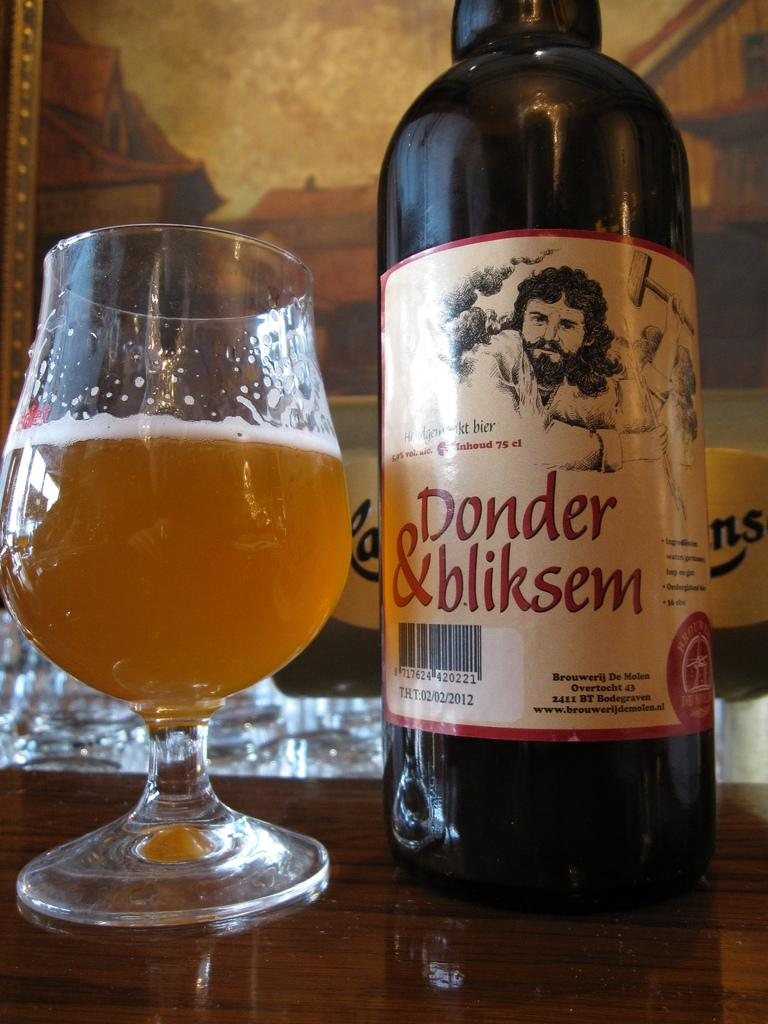<image>
Give a short and clear explanation of the subsequent image. A bottle has the brand name Donder and bliksem and is next to a glass. 